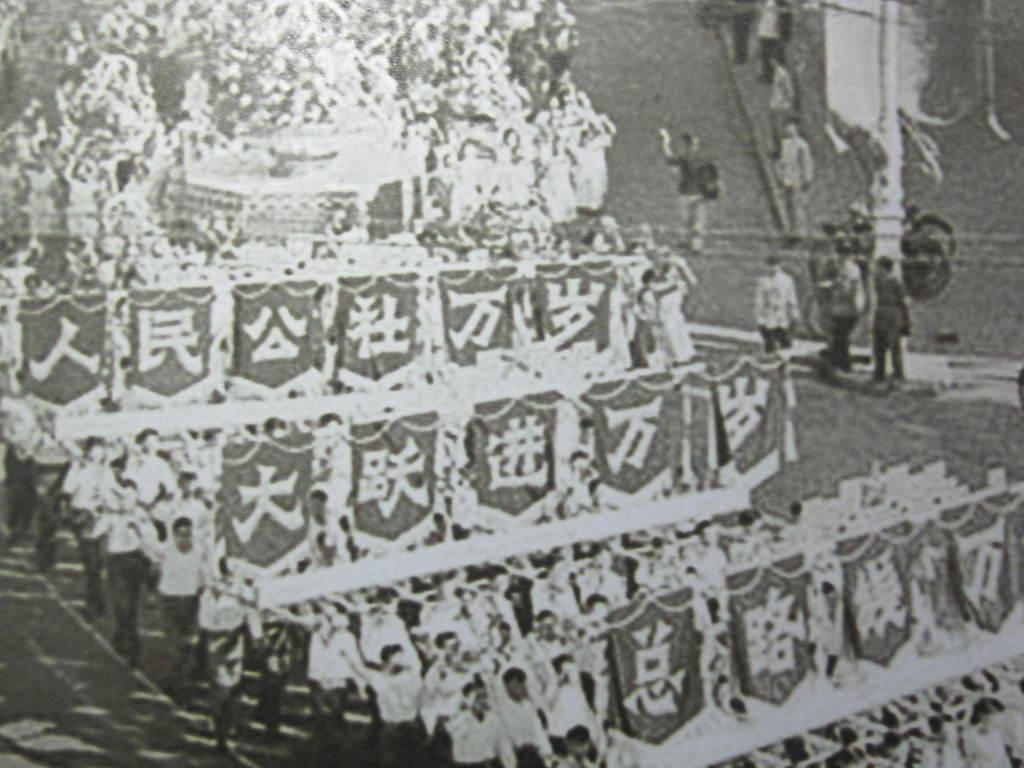What is the color scheme of the image? The image is black and white. What can be seen in the image? There are people in the image. What are the people doing in the image? The people are marching. What are the people holding in their hands? The people are holding flags in their hands. How many sponges can be seen in the image? There are no sponges present in the image. What type of memory is being displayed by the people in the image? The image does not show any specific memories; it simply depicts people marching with flags. 